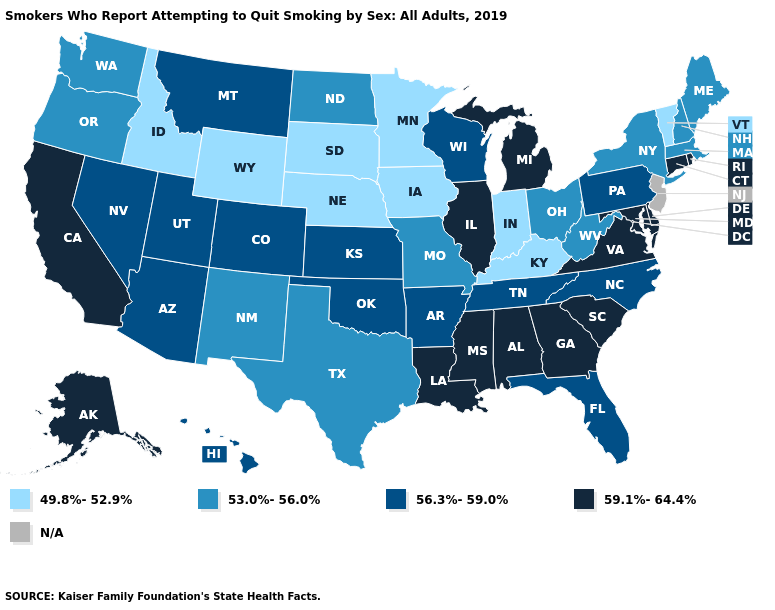Among the states that border Arkansas , does Tennessee have the highest value?
Be succinct. No. Among the states that border South Carolina , which have the lowest value?
Answer briefly. North Carolina. What is the value of Massachusetts?
Quick response, please. 53.0%-56.0%. Does Alabama have the highest value in the USA?
Concise answer only. Yes. Name the states that have a value in the range 49.8%-52.9%?
Quick response, please. Idaho, Indiana, Iowa, Kentucky, Minnesota, Nebraska, South Dakota, Vermont, Wyoming. What is the value of Idaho?
Be succinct. 49.8%-52.9%. What is the highest value in the West ?
Be succinct. 59.1%-64.4%. Name the states that have a value in the range 56.3%-59.0%?
Be succinct. Arizona, Arkansas, Colorado, Florida, Hawaii, Kansas, Montana, Nevada, North Carolina, Oklahoma, Pennsylvania, Tennessee, Utah, Wisconsin. Does Oklahoma have the highest value in the South?
Quick response, please. No. What is the highest value in states that border California?
Quick response, please. 56.3%-59.0%. What is the value of Maine?
Give a very brief answer. 53.0%-56.0%. What is the highest value in the West ?
Write a very short answer. 59.1%-64.4%. Name the states that have a value in the range 59.1%-64.4%?
Concise answer only. Alabama, Alaska, California, Connecticut, Delaware, Georgia, Illinois, Louisiana, Maryland, Michigan, Mississippi, Rhode Island, South Carolina, Virginia. What is the value of Maryland?
Answer briefly. 59.1%-64.4%. What is the lowest value in states that border Rhode Island?
Keep it brief. 53.0%-56.0%. 